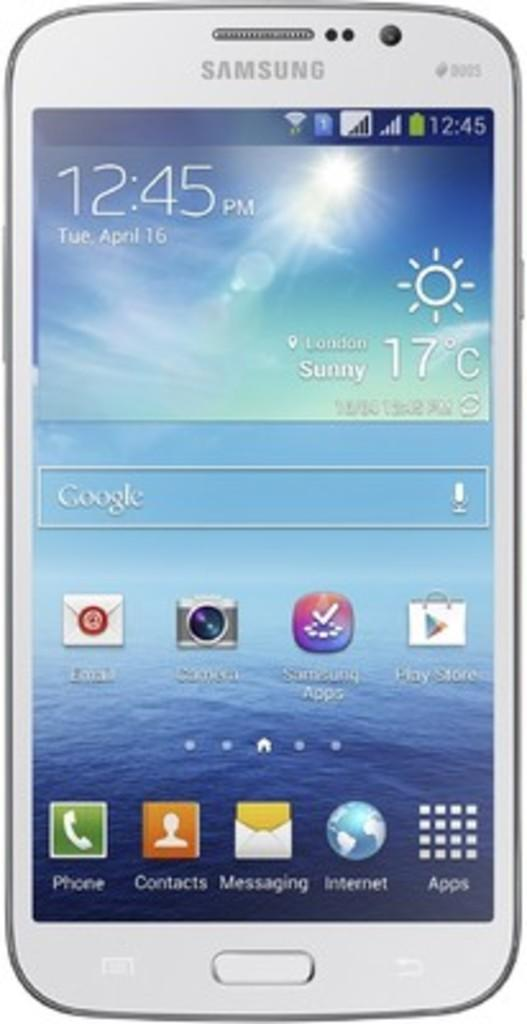Provide a one-sentence caption for the provided image. Samsung phone with the home screen showing the apps and time. 